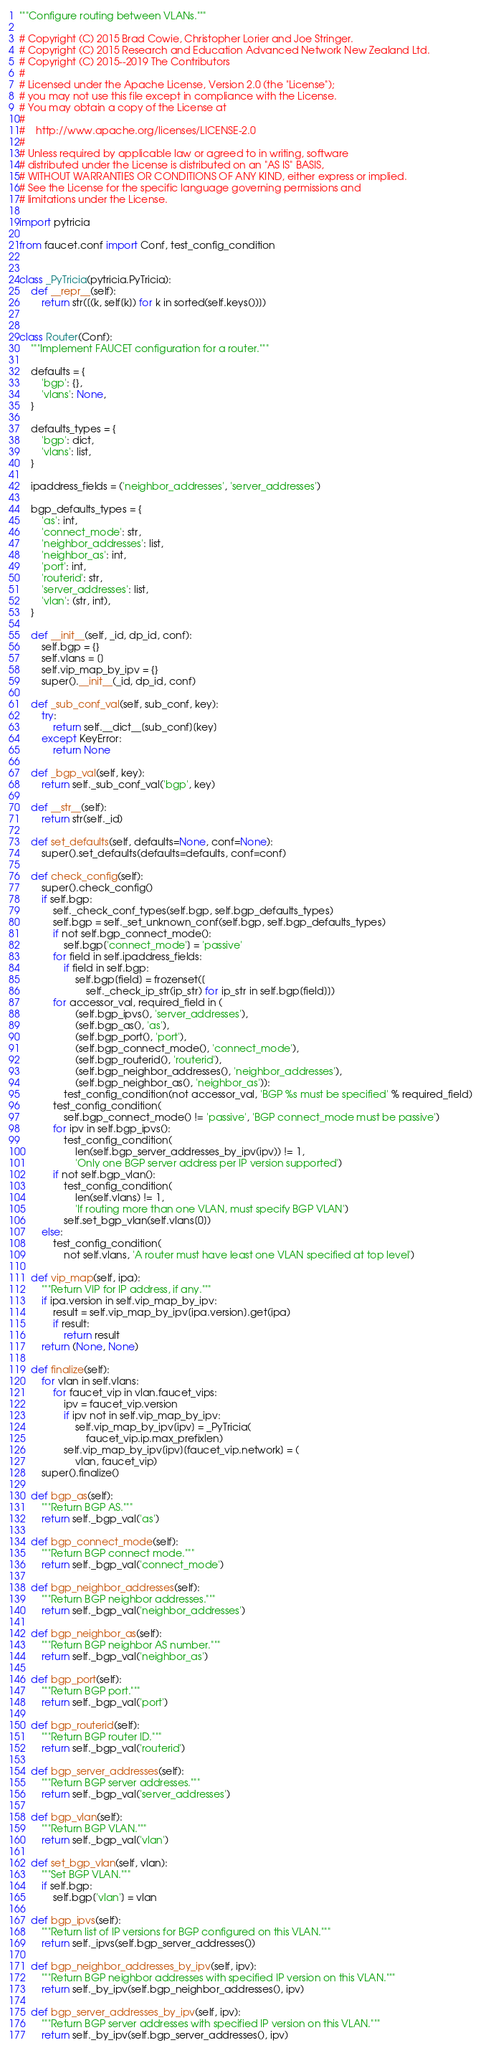Convert code to text. <code><loc_0><loc_0><loc_500><loc_500><_Python_>"""Configure routing between VLANs."""

# Copyright (C) 2015 Brad Cowie, Christopher Lorier and Joe Stringer.
# Copyright (C) 2015 Research and Education Advanced Network New Zealand Ltd.
# Copyright (C) 2015--2019 The Contributors
#
# Licensed under the Apache License, Version 2.0 (the "License");
# you may not use this file except in compliance with the License.
# You may obtain a copy of the License at
#
#    http://www.apache.org/licenses/LICENSE-2.0
#
# Unless required by applicable law or agreed to in writing, software
# distributed under the License is distributed on an "AS IS" BASIS,
# WITHOUT WARRANTIES OR CONDITIONS OF ANY KIND, either express or implied.
# See the License for the specific language governing permissions and
# limitations under the License.

import pytricia

from faucet.conf import Conf, test_config_condition


class _PyTricia(pytricia.PyTricia):
    def __repr__(self):
        return str([(k, self[k]) for k in sorted(self.keys())])


class Router(Conf):
    """Implement FAUCET configuration for a router."""

    defaults = {
        'bgp': {},
        'vlans': None,
    }

    defaults_types = {
        'bgp': dict,
        'vlans': list,
    }

    ipaddress_fields = ('neighbor_addresses', 'server_addresses')

    bgp_defaults_types = {
        'as': int,
        'connect_mode': str,
        'neighbor_addresses': list,
        'neighbor_as': int,
        'port': int,
        'routerid': str,
        'server_addresses': list,
        'vlan': (str, int),
    }

    def __init__(self, _id, dp_id, conf):
        self.bgp = {}
        self.vlans = []
        self.vip_map_by_ipv = {}
        super().__init__(_id, dp_id, conf)

    def _sub_conf_val(self, sub_conf, key):
        try:
            return self.__dict__[sub_conf][key]
        except KeyError:
            return None

    def _bgp_val(self, key):
        return self._sub_conf_val('bgp', key)

    def __str__(self):
        return str(self._id)

    def set_defaults(self, defaults=None, conf=None):
        super().set_defaults(defaults=defaults, conf=conf)

    def check_config(self):
        super().check_config()
        if self.bgp:
            self._check_conf_types(self.bgp, self.bgp_defaults_types)
            self.bgp = self._set_unknown_conf(self.bgp, self.bgp_defaults_types)
            if not self.bgp_connect_mode():
                self.bgp['connect_mode'] = 'passive'
            for field in self.ipaddress_fields:
                if field in self.bgp:
                    self.bgp[field] = frozenset([
                        self._check_ip_str(ip_str) for ip_str in self.bgp[field]])
            for accessor_val, required_field in (
                    (self.bgp_ipvs(), 'server_addresses'),
                    (self.bgp_as(), 'as'),
                    (self.bgp_port(), 'port'),
                    (self.bgp_connect_mode(), 'connect_mode'),
                    (self.bgp_routerid(), 'routerid'),
                    (self.bgp_neighbor_addresses(), 'neighbor_addresses'),
                    (self.bgp_neighbor_as(), 'neighbor_as')):
                test_config_condition(not accessor_val, 'BGP %s must be specified' % required_field)
            test_config_condition(
                self.bgp_connect_mode() != 'passive', 'BGP connect_mode must be passive')
            for ipv in self.bgp_ipvs():
                test_config_condition(
                    len(self.bgp_server_addresses_by_ipv(ipv)) != 1,
                    'Only one BGP server address per IP version supported')
            if not self.bgp_vlan():
                test_config_condition(
                    len(self.vlans) != 1,
                    'If routing more than one VLAN, must specify BGP VLAN')
                self.set_bgp_vlan(self.vlans[0])
        else:
            test_config_condition(
                not self.vlans, 'A router must have least one VLAN specified at top level')

    def vip_map(self, ipa):
        """Return VIP for IP address, if any."""
        if ipa.version in self.vip_map_by_ipv:
            result = self.vip_map_by_ipv[ipa.version].get(ipa)
            if result:
                return result
        return (None, None)

    def finalize(self):
        for vlan in self.vlans:
            for faucet_vip in vlan.faucet_vips:
                ipv = faucet_vip.version
                if ipv not in self.vip_map_by_ipv:
                    self.vip_map_by_ipv[ipv] = _PyTricia(
                        faucet_vip.ip.max_prefixlen)
                self.vip_map_by_ipv[ipv][faucet_vip.network] = (
                    vlan, faucet_vip)
        super().finalize()

    def bgp_as(self):
        """Return BGP AS."""
        return self._bgp_val('as')

    def bgp_connect_mode(self):
        """Return BGP connect mode."""
        return self._bgp_val('connect_mode')

    def bgp_neighbor_addresses(self):
        """Return BGP neighbor addresses."""
        return self._bgp_val('neighbor_addresses')

    def bgp_neighbor_as(self):
        """Return BGP neighbor AS number."""
        return self._bgp_val('neighbor_as')

    def bgp_port(self):
        """Return BGP port."""
        return self._bgp_val('port')

    def bgp_routerid(self):
        """Return BGP router ID."""
        return self._bgp_val('routerid')

    def bgp_server_addresses(self):
        """Return BGP server addresses."""
        return self._bgp_val('server_addresses')

    def bgp_vlan(self):
        """Return BGP VLAN."""
        return self._bgp_val('vlan')

    def set_bgp_vlan(self, vlan):
        """Set BGP VLAN."""
        if self.bgp:
            self.bgp['vlan'] = vlan

    def bgp_ipvs(self):
        """Return list of IP versions for BGP configured on this VLAN."""
        return self._ipvs(self.bgp_server_addresses())

    def bgp_neighbor_addresses_by_ipv(self, ipv):
        """Return BGP neighbor addresses with specified IP version on this VLAN."""
        return self._by_ipv(self.bgp_neighbor_addresses(), ipv)

    def bgp_server_addresses_by_ipv(self, ipv):
        """Return BGP server addresses with specified IP version on this VLAN."""
        return self._by_ipv(self.bgp_server_addresses(), ipv)
</code> 